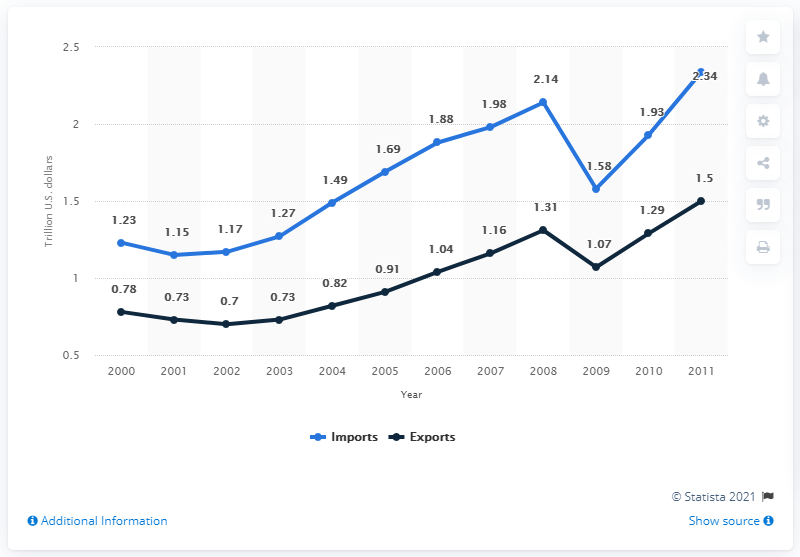Indicate a few pertinent items in this graphic. The dark blue line represents exports. In 2010, the total value of U.S. imports of goods was $1.93 trillion. The average of imports for the last 3 years is 1.95. 